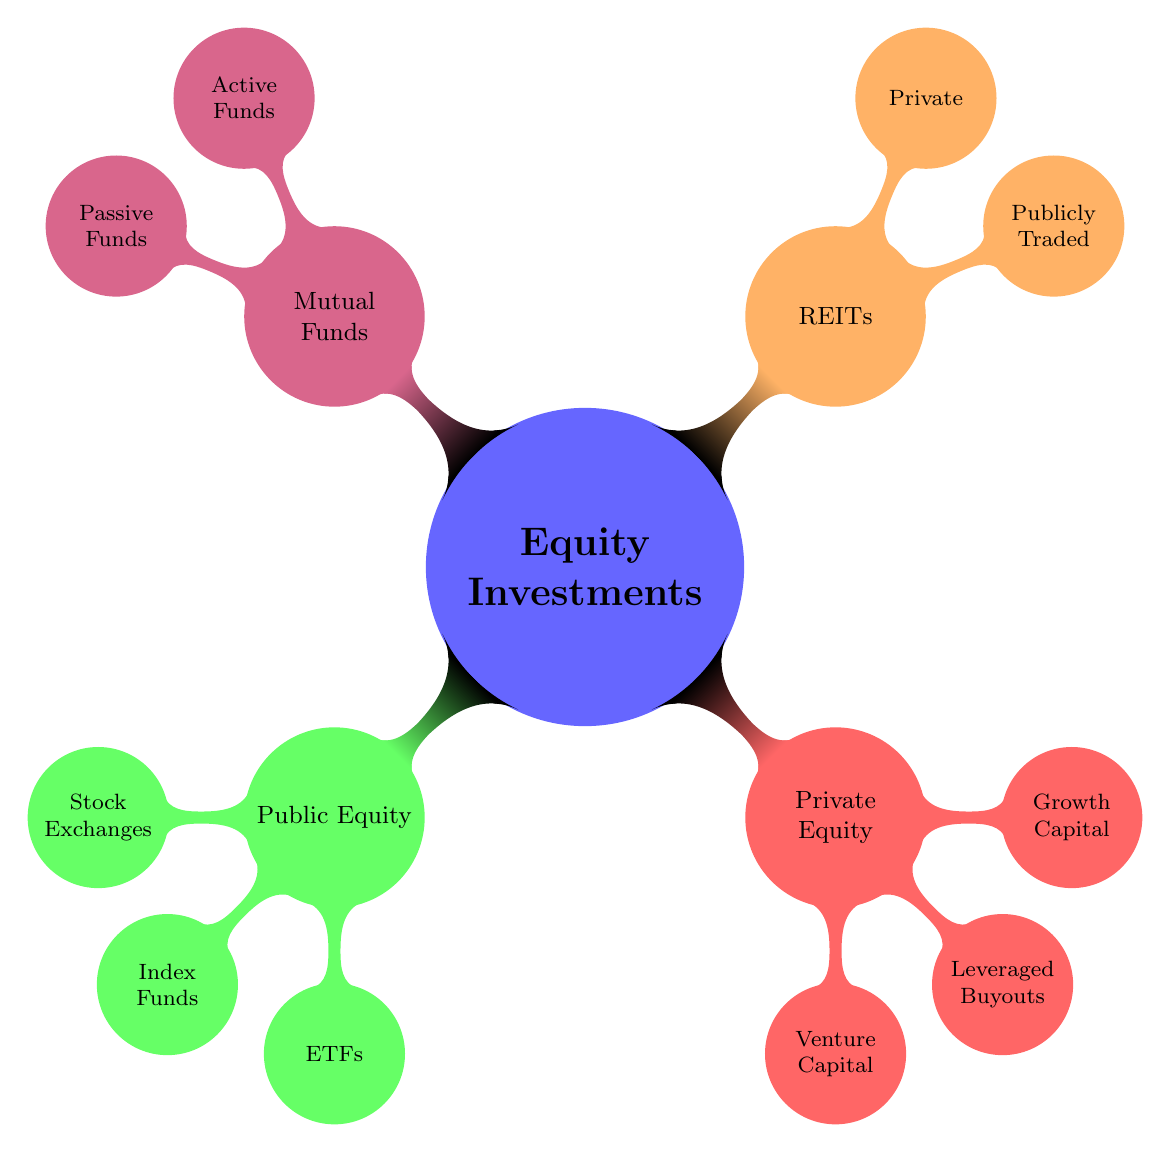What are the four main branches of Equity Investments? The diagram shows four main branches under Equity Investments: Public Equity, Private Equity, Real Estate Investment Trusts (REITs), and Mutual Funds.
Answer: Public Equity, Private Equity, REITs, Mutual Funds How many nodes are there under Public Equity? Under Public Equity, there are three nodes: Stock Exchanges, Index Funds, and ETFs. Adding these gives a total of three nodes.
Answer: 3 What type of investment is Sequoia Capital associated with? Sequoia Capital is a node under the Venture Capital branch of Private Equity, indicating it is associated with venture capital investments.
Answer: Venture Capital Name one fund listed under Passive Funds. The Passive Funds branch includes Vanguard Total Stock Market Index Fund, Schwab S&P 500 Index Fund, and Fidelity 500 Index Fund. Any one of these can be the answer.
Answer: Vanguard Total Stock Market Index Fund Which branch has a subset with two types of REITs? The REITs branch has two subsets: Publicly Traded REITs and Private REITs. This indicates the categorization under REITs.
Answer: REITs How many Exchange-Traded Funds (ETFs) are listed in the diagram? The ETFs under Public Equity have three listed: SPDR S&P 500 ETF Trust, Vanguard FTSE All-World, and iShares MSCI Emerging Markets ETF. Thus, there are three ETFs listed.
Answer: 3 What is the relationship between Active Funds and Mutual Funds? Active Funds is a subtype under the Mutual Funds branch, indicating that Active Funds are a specific category within the broader category of Mutual Funds.
Answer: Active Funds Which node shows the highest number of types listed? The Private Equity branch has three types listed: Venture Capital, Leveraged Buyouts, and Growth Capital. No other branch has more than three types, so it has the highest number.
Answer: Private Equity 